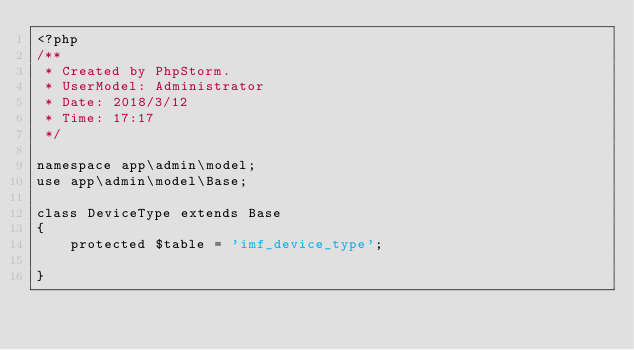<code> <loc_0><loc_0><loc_500><loc_500><_PHP_><?php
/**
 * Created by PhpStorm.
 * UserModel: Administrator
 * Date: 2018/3/12
 * Time: 17:17
 */

namespace app\admin\model;
use app\admin\model\Base;

class DeviceType extends Base
{
    protected $table = 'imf_device_type';

}</code> 